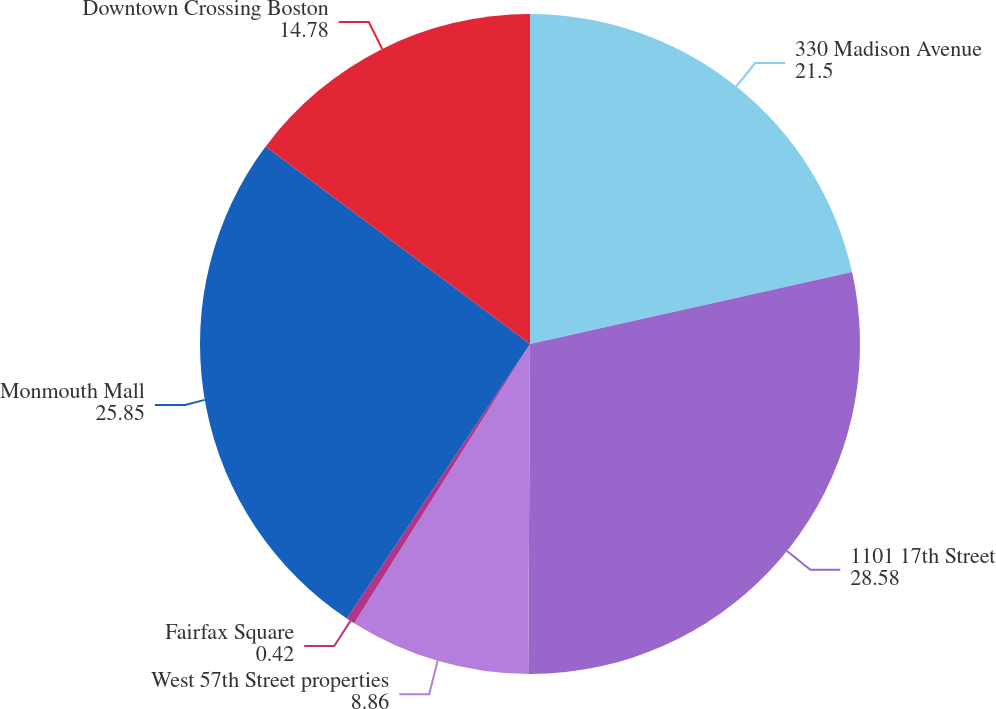Convert chart. <chart><loc_0><loc_0><loc_500><loc_500><pie_chart><fcel>330 Madison Avenue<fcel>1101 17th Street<fcel>West 57th Street properties<fcel>Fairfax Square<fcel>Monmouth Mall<fcel>Downtown Crossing Boston<nl><fcel>21.5%<fcel>28.58%<fcel>8.86%<fcel>0.42%<fcel>25.85%<fcel>14.78%<nl></chart> 